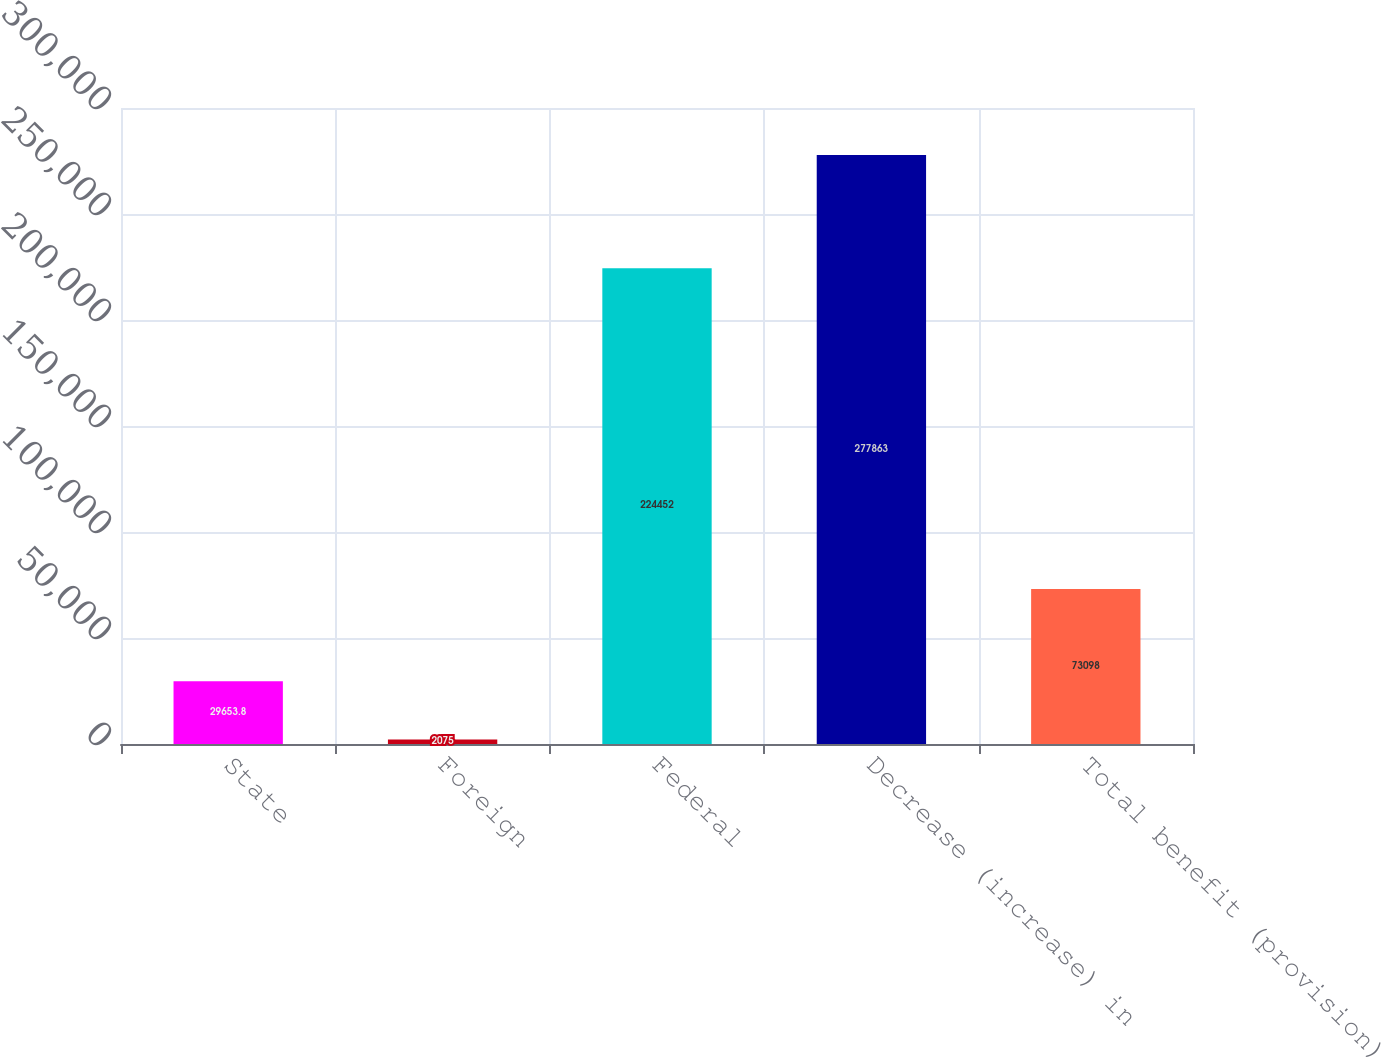Convert chart. <chart><loc_0><loc_0><loc_500><loc_500><bar_chart><fcel>State<fcel>Foreign<fcel>Federal<fcel>Decrease (increase) in<fcel>Total benefit (provision)<nl><fcel>29653.8<fcel>2075<fcel>224452<fcel>277863<fcel>73098<nl></chart> 